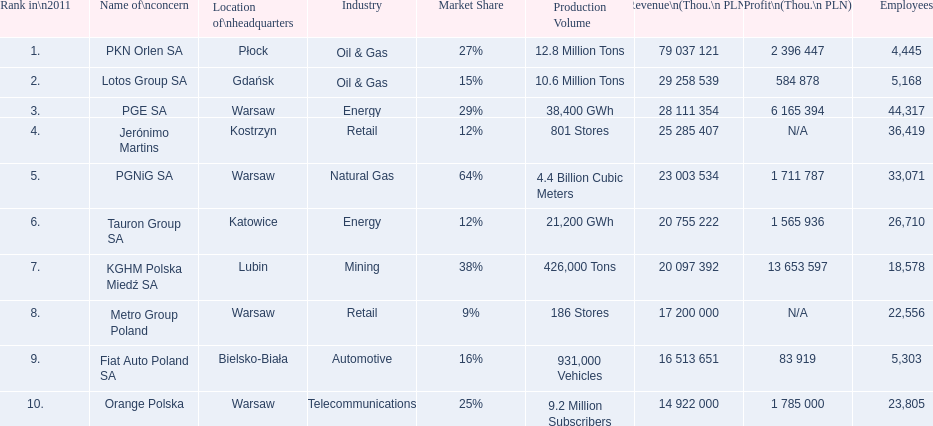Which concern's headquarters are located in warsaw? PGE SA, PGNiG SA, Metro Group Poland. Which of these listed a profit? PGE SA, PGNiG SA. Of these how many employees are in the concern with the lowest profit? 33,071. 